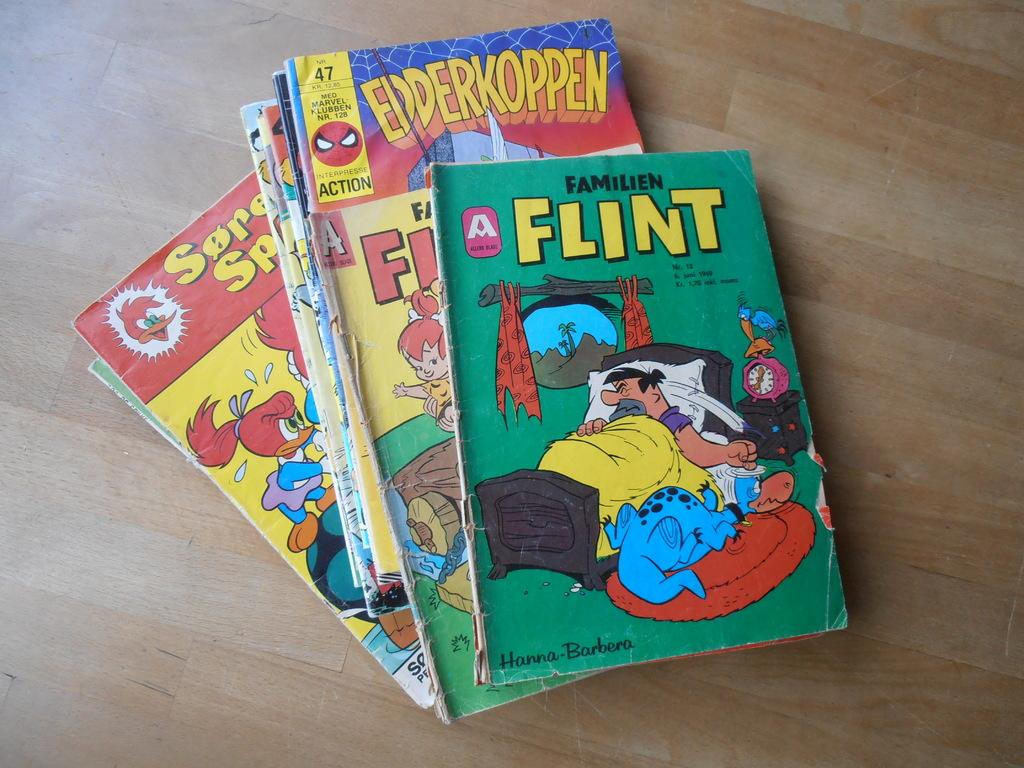<image>
Write a terse but informative summary of the picture. Green book called FLINT showing a man in his bed and his dinosaur. 